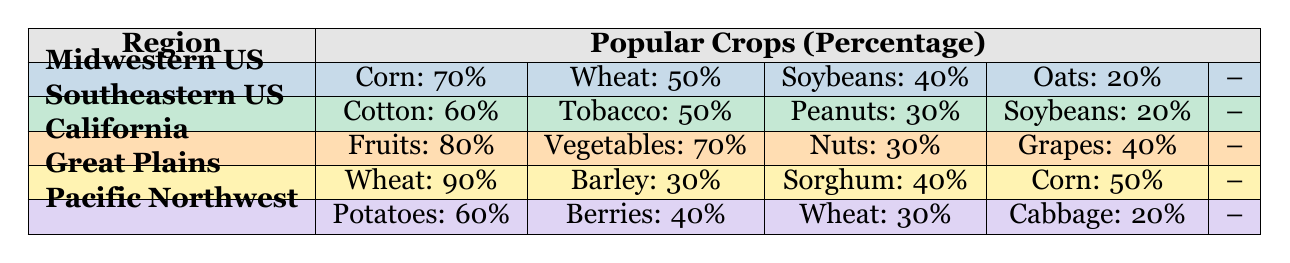What is the most popular crop in the Great Plains region? According to the table, the most popular crop in the Great Plains is wheat, which has a percentage of 90%.
Answer: Wheat Which region has the highest percentage of corn? The table shows that the Midwestern United States has the highest percentage of corn at 70%.
Answer: Midwestern United States What are the total percentages of tobacco and cotton in the Southeastern United States? The percentage of tobacco is 50% and cotton is 60%. Adding these gives a total of 110%.
Answer: 110% Is it true that the Pacific Northwest grows more berries than potatoes? In the table, the percentage for potatoes is 60% and berries is 40%. This means the statement is false since potatoes are more prevalent.
Answer: No Which region grows fruits at the highest percentage? The data indicates that California grows fruits at 80%, which is the highest percentage among the regions listed.
Answer: California If you average the percentage of vegetables in California and wheat in the Great Plains, what do you get? In California, the percentage of vegetables is 70% and in the Great Plains, the percentage of wheat is 90%. The average is (70 + 90) / 2 = 80%.
Answer: 80% Does the Midwestern United States grow more oats than soybeans? The table shows oats at 20% and soybeans at 40% in the Midwestern United States. Since 20% is less than 40%, this statement is false.
Answer: No Which region has the least popular crop among those listed, based on the percentages? Oats at 20% in the Midwestern United States is the least popular crop when compared to the others listed in the table.
Answer: Oats What is the combined percentage of soybeans in the Midwestern and Southeastern United States? For the Midwestern United States, soybeans are at 40%, and for the Southeastern United States, they are at 20%. The combination is 40 + 20 = 60%.
Answer: 60% 